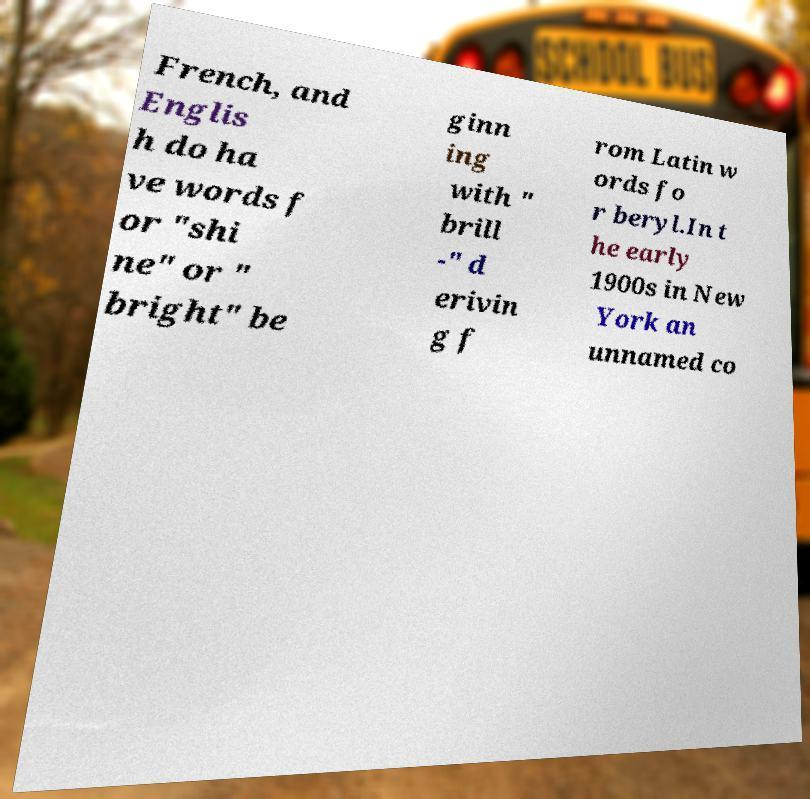Please read and relay the text visible in this image. What does it say? French, and Englis h do ha ve words f or "shi ne" or " bright" be ginn ing with " brill -" d erivin g f rom Latin w ords fo r beryl.In t he early 1900s in New York an unnamed co 